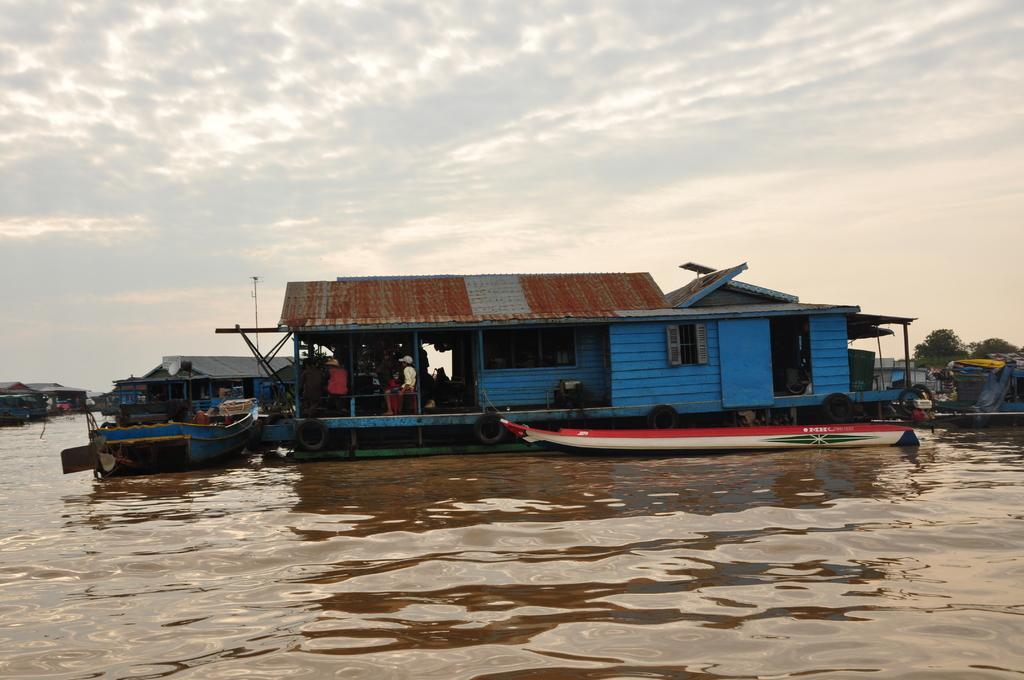Could you give a brief overview of what you see in this image? This picture is clicked outside. In the center we can see the boats and the boat house in the water body and we can see the group of people in the boat house. In the background we can see the sky, trees and some other objects. In the left corner we can see the objects which seems to be the boat houses. 